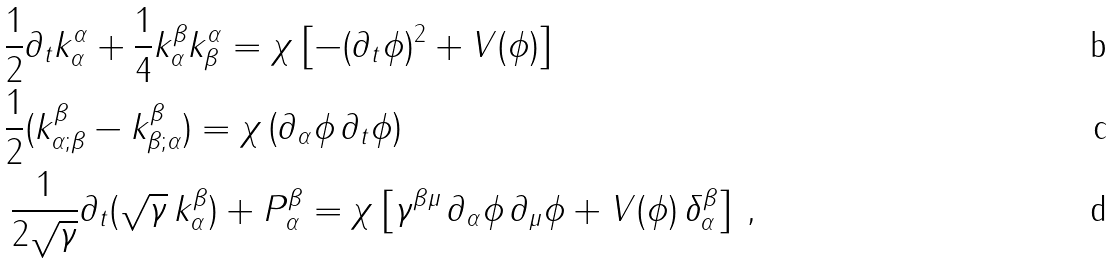Convert formula to latex. <formula><loc_0><loc_0><loc_500><loc_500>& \frac { 1 } { 2 } \partial _ { t } k _ { \alpha } ^ { \alpha } + \frac { 1 } { 4 } k _ { \alpha } ^ { \beta } k _ { \beta } ^ { \alpha } = \chi \left [ - ( \partial _ { t } \phi ) ^ { 2 } + V ( \phi ) \right ] \\ & \frac { 1 } { 2 } ( k ^ { \beta } _ { \alpha ; \beta } - k ^ { \beta } _ { \beta ; \alpha } ) = \chi \left ( \partial _ { \alpha } \phi \, \partial _ { t } \phi \right ) \\ & \, \frac { 1 } { 2 \sqrt { \gamma } } \partial _ { t } ( \sqrt { \gamma } \, k _ { \alpha } ^ { \beta } ) + P _ { \alpha } ^ { \beta } = \chi \left [ { \gamma } ^ { \beta \mu } \, \partial _ { \alpha } \phi \, \partial _ { \mu } \phi + V ( \phi ) \, { \delta } _ { \alpha } ^ { \beta } \right ] \, ,</formula> 